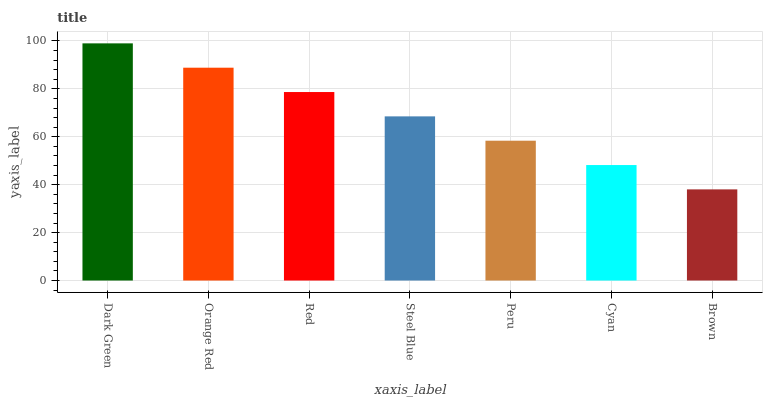Is Brown the minimum?
Answer yes or no. Yes. Is Dark Green the maximum?
Answer yes or no. Yes. Is Orange Red the minimum?
Answer yes or no. No. Is Orange Red the maximum?
Answer yes or no. No. Is Dark Green greater than Orange Red?
Answer yes or no. Yes. Is Orange Red less than Dark Green?
Answer yes or no. Yes. Is Orange Red greater than Dark Green?
Answer yes or no. No. Is Dark Green less than Orange Red?
Answer yes or no. No. Is Steel Blue the high median?
Answer yes or no. Yes. Is Steel Blue the low median?
Answer yes or no. Yes. Is Red the high median?
Answer yes or no. No. Is Red the low median?
Answer yes or no. No. 